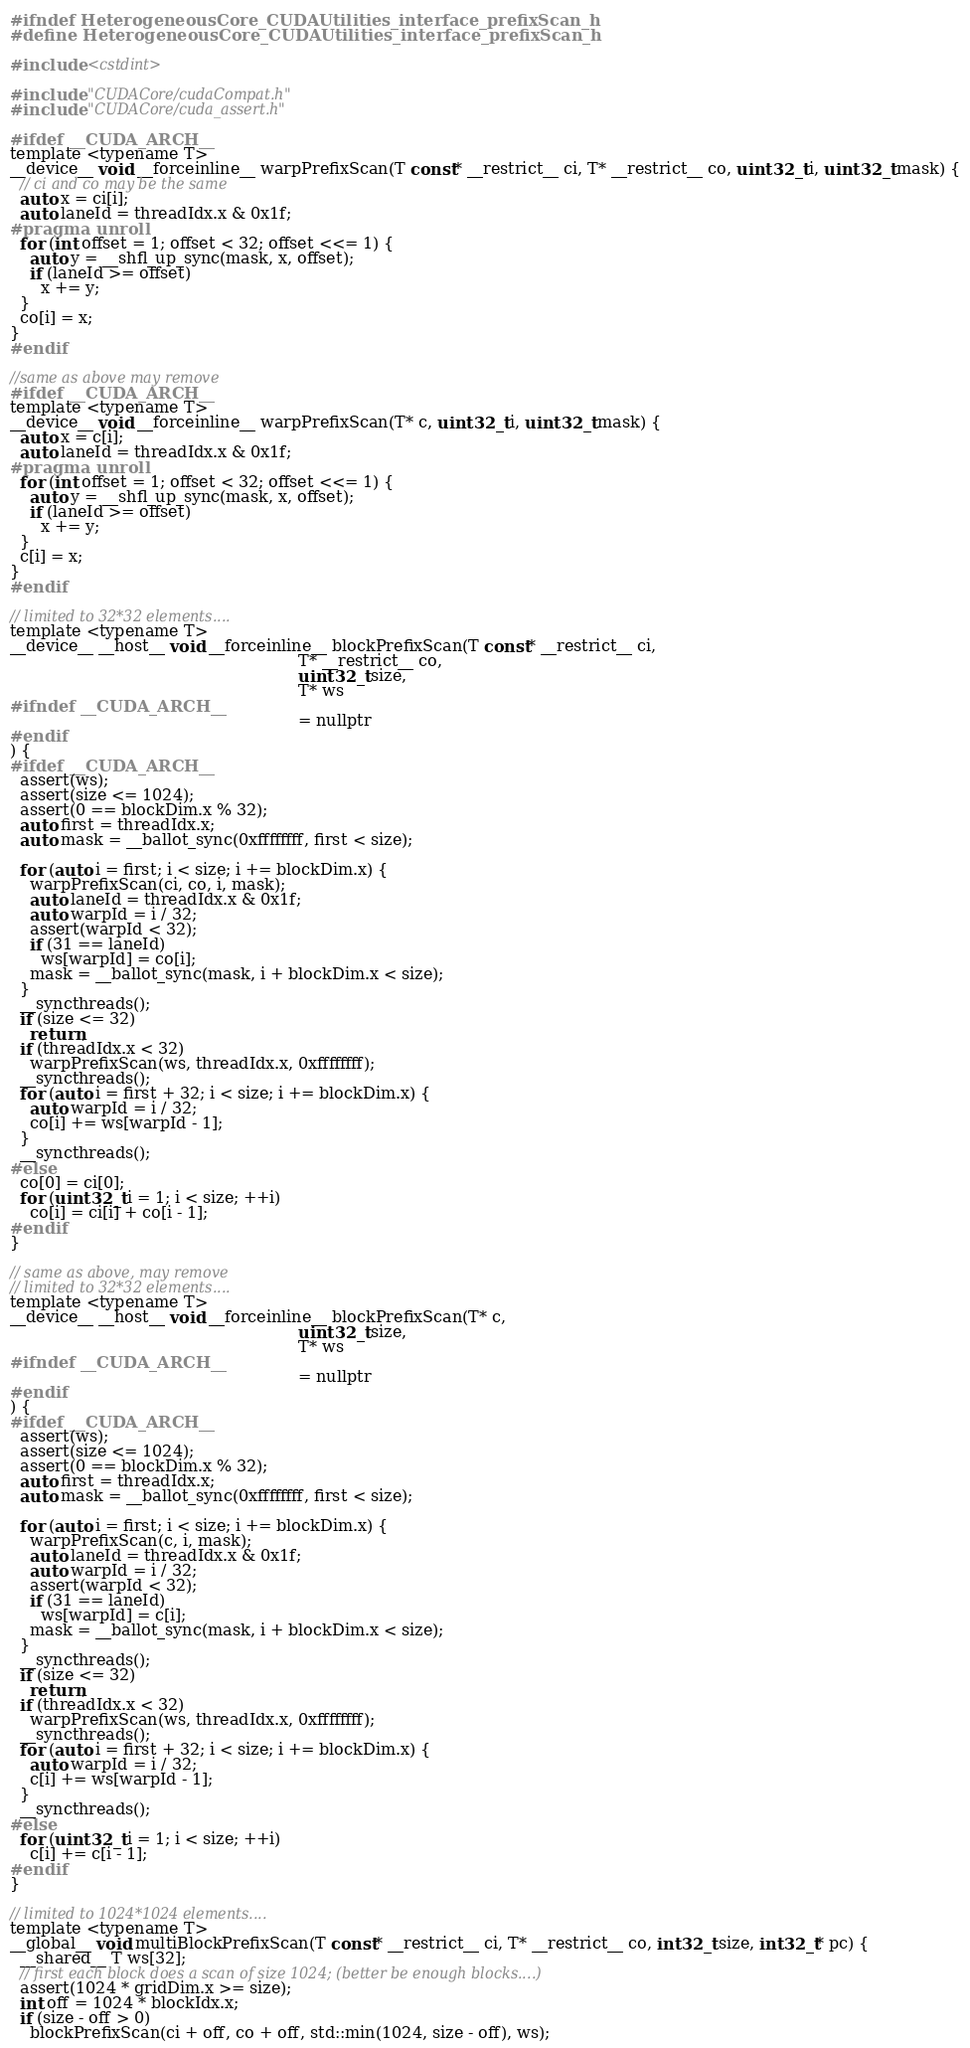Convert code to text. <code><loc_0><loc_0><loc_500><loc_500><_C_>#ifndef HeterogeneousCore_CUDAUtilities_interface_prefixScan_h
#define HeterogeneousCore_CUDAUtilities_interface_prefixScan_h

#include <cstdint>

#include "CUDACore/cudaCompat.h"
#include "CUDACore/cuda_assert.h"

#ifdef __CUDA_ARCH__
template <typename T>
__device__ void __forceinline__ warpPrefixScan(T const* __restrict__ ci, T* __restrict__ co, uint32_t i, uint32_t mask) {
  // ci and co may be the same
  auto x = ci[i];
  auto laneId = threadIdx.x & 0x1f;
#pragma unroll
  for (int offset = 1; offset < 32; offset <<= 1) {
    auto y = __shfl_up_sync(mask, x, offset);
    if (laneId >= offset)
      x += y;
  }
  co[i] = x;
}
#endif

//same as above may remove
#ifdef __CUDA_ARCH__
template <typename T>
__device__ void __forceinline__ warpPrefixScan(T* c, uint32_t i, uint32_t mask) {
  auto x = c[i];
  auto laneId = threadIdx.x & 0x1f;
#pragma unroll
  for (int offset = 1; offset < 32; offset <<= 1) {
    auto y = __shfl_up_sync(mask, x, offset);
    if (laneId >= offset)
      x += y;
  }
  c[i] = x;
}
#endif

// limited to 32*32 elements....
template <typename T>
__device__ __host__ void __forceinline__ blockPrefixScan(T const* __restrict__ ci,
                                                         T* __restrict__ co,
                                                         uint32_t size,
                                                         T* ws
#ifndef __CUDA_ARCH__
                                                         = nullptr
#endif
) {
#ifdef __CUDA_ARCH__
  assert(ws);
  assert(size <= 1024);
  assert(0 == blockDim.x % 32);
  auto first = threadIdx.x;
  auto mask = __ballot_sync(0xffffffff, first < size);

  for (auto i = first; i < size; i += blockDim.x) {
    warpPrefixScan(ci, co, i, mask);
    auto laneId = threadIdx.x & 0x1f;
    auto warpId = i / 32;
    assert(warpId < 32);
    if (31 == laneId)
      ws[warpId] = co[i];
    mask = __ballot_sync(mask, i + blockDim.x < size);
  }
  __syncthreads();
  if (size <= 32)
    return;
  if (threadIdx.x < 32)
    warpPrefixScan(ws, threadIdx.x, 0xffffffff);
  __syncthreads();
  for (auto i = first + 32; i < size; i += blockDim.x) {
    auto warpId = i / 32;
    co[i] += ws[warpId - 1];
  }
  __syncthreads();
#else
  co[0] = ci[0];
  for (uint32_t i = 1; i < size; ++i)
    co[i] = ci[i] + co[i - 1];
#endif
}

// same as above, may remove
// limited to 32*32 elements....
template <typename T>
__device__ __host__ void __forceinline__ blockPrefixScan(T* c,
                                                         uint32_t size,
                                                         T* ws
#ifndef __CUDA_ARCH__
                                                         = nullptr
#endif
) {
#ifdef __CUDA_ARCH__
  assert(ws);
  assert(size <= 1024);
  assert(0 == blockDim.x % 32);
  auto first = threadIdx.x;
  auto mask = __ballot_sync(0xffffffff, first < size);

  for (auto i = first; i < size; i += blockDim.x) {
    warpPrefixScan(c, i, mask);
    auto laneId = threadIdx.x & 0x1f;
    auto warpId = i / 32;
    assert(warpId < 32);
    if (31 == laneId)
      ws[warpId] = c[i];
    mask = __ballot_sync(mask, i + blockDim.x < size);
  }
  __syncthreads();
  if (size <= 32)
    return;
  if (threadIdx.x < 32)
    warpPrefixScan(ws, threadIdx.x, 0xffffffff);
  __syncthreads();
  for (auto i = first + 32; i < size; i += blockDim.x) {
    auto warpId = i / 32;
    c[i] += ws[warpId - 1];
  }
  __syncthreads();
#else
  for (uint32_t i = 1; i < size; ++i)
    c[i] += c[i - 1];
#endif
}

// limited to 1024*1024 elements....
template <typename T>
__global__ void multiBlockPrefixScan(T const* __restrict__ ci, T* __restrict__ co, int32_t size, int32_t* pc) {
  __shared__ T ws[32];
  // first each block does a scan of size 1024; (better be enough blocks....)
  assert(1024 * gridDim.x >= size);
  int off = 1024 * blockIdx.x;
  if (size - off > 0)
    blockPrefixScan(ci + off, co + off, std::min(1024, size - off), ws);
</code> 